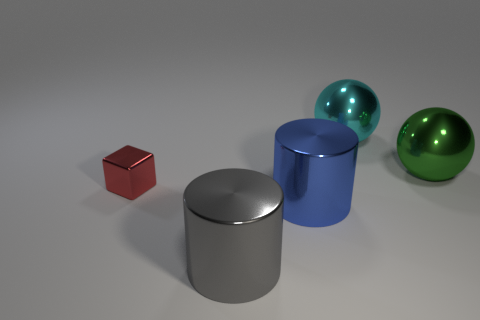Is there anything else that has the same size as the shiny block?
Make the answer very short. No. There is a metallic cylinder in front of the blue metal object; is it the same size as the large green object?
Your response must be concise. Yes. Is there a metallic ball of the same size as the gray object?
Keep it short and to the point. Yes. What number of other objects are there of the same shape as the small object?
Your answer should be compact. 0. What shape is the shiny thing on the left side of the gray object?
Provide a short and direct response. Cube. There is a blue object; does it have the same shape as the big metallic object in front of the big blue shiny object?
Your response must be concise. Yes. There is a metallic thing that is on the left side of the big blue metallic cylinder and behind the gray cylinder; what is its size?
Your response must be concise. Small. There is a object that is to the left of the green ball and right of the large blue metal thing; what color is it?
Your answer should be very brief. Cyan. Are there fewer small red metallic blocks that are right of the big blue object than large metal cylinders behind the gray metal cylinder?
Offer a very short reply. Yes. What shape is the gray metal thing?
Ensure brevity in your answer.  Cylinder. 